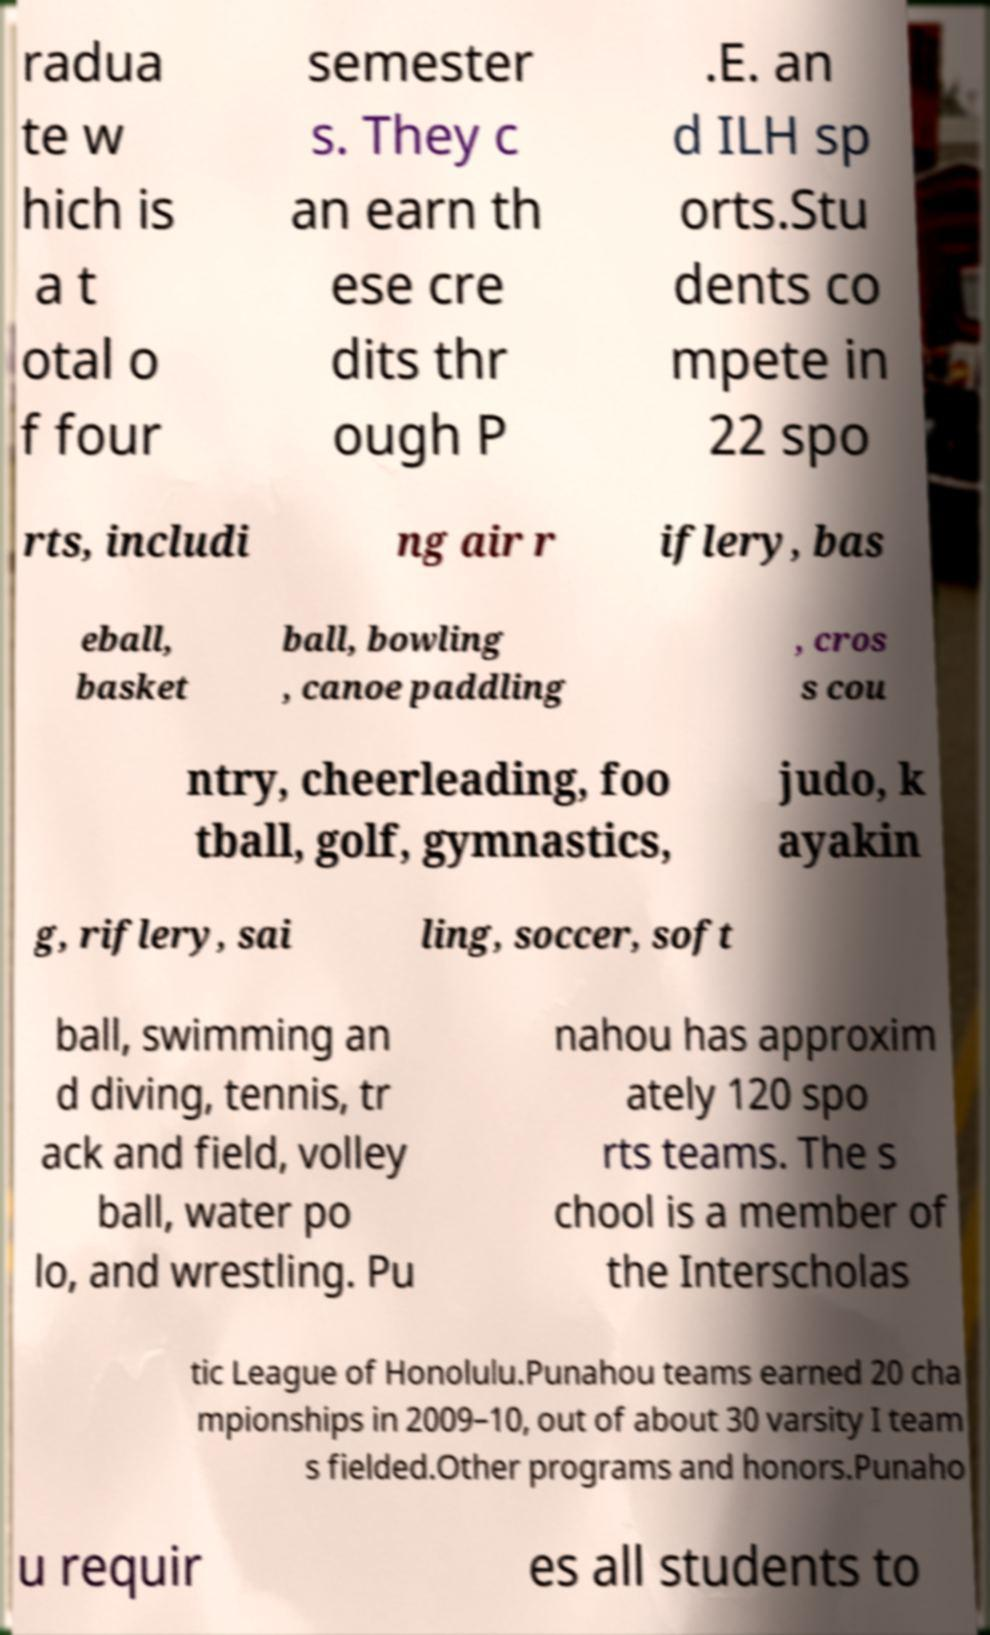Please read and relay the text visible in this image. What does it say? radua te w hich is a t otal o f four semester s. They c an earn th ese cre dits thr ough P .E. an d ILH sp orts.Stu dents co mpete in 22 spo rts, includi ng air r iflery, bas eball, basket ball, bowling , canoe paddling , cros s cou ntry, cheerleading, foo tball, golf, gymnastics, judo, k ayakin g, riflery, sai ling, soccer, soft ball, swimming an d diving, tennis, tr ack and field, volley ball, water po lo, and wrestling. Pu nahou has approxim ately 120 spo rts teams. The s chool is a member of the Interscholas tic League of Honolulu.Punahou teams earned 20 cha mpionships in 2009–10, out of about 30 varsity I team s fielded.Other programs and honors.Punaho u requir es all students to 